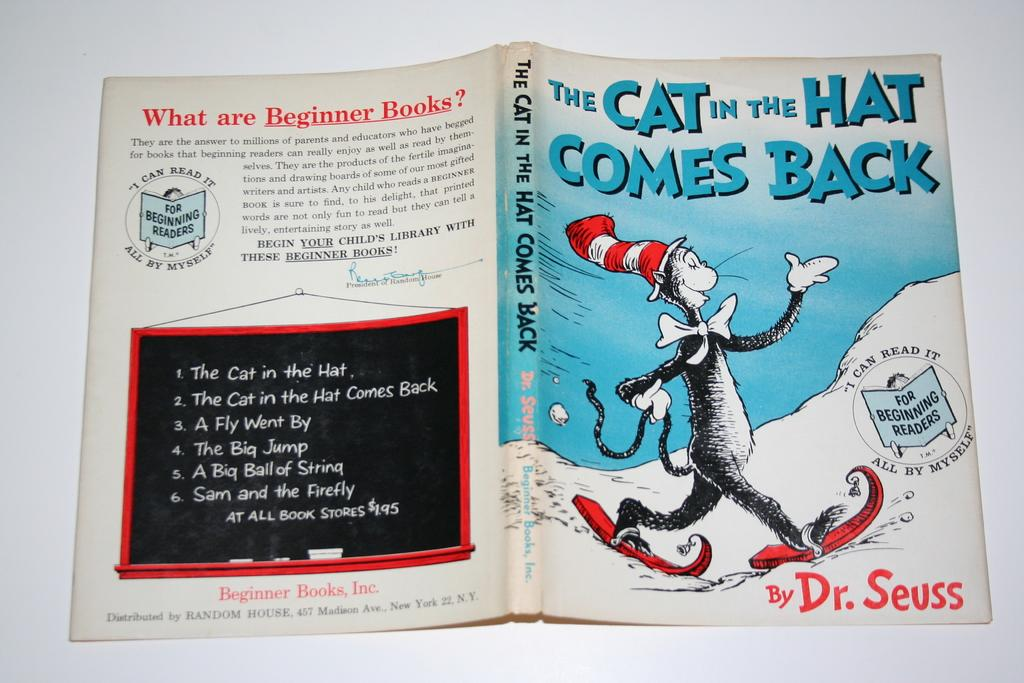Provide a one-sentence caption for the provided image. The cover of a book with a black and white cat by Dr. Seuss. 